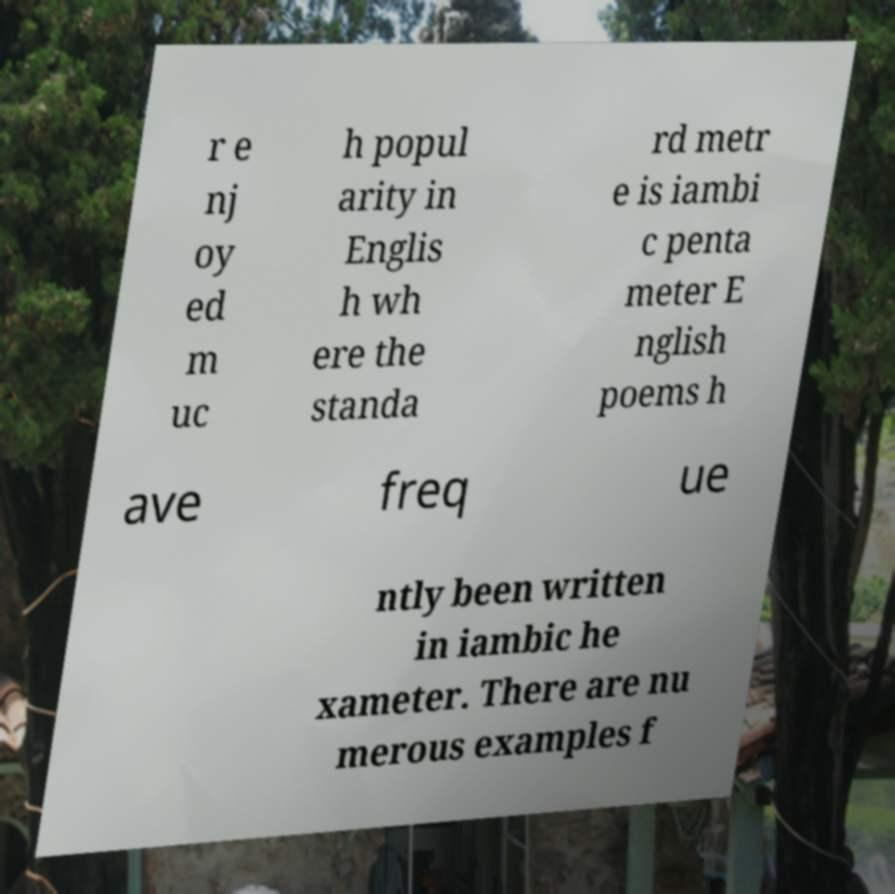For documentation purposes, I need the text within this image transcribed. Could you provide that? r e nj oy ed m uc h popul arity in Englis h wh ere the standa rd metr e is iambi c penta meter E nglish poems h ave freq ue ntly been written in iambic he xameter. There are nu merous examples f 